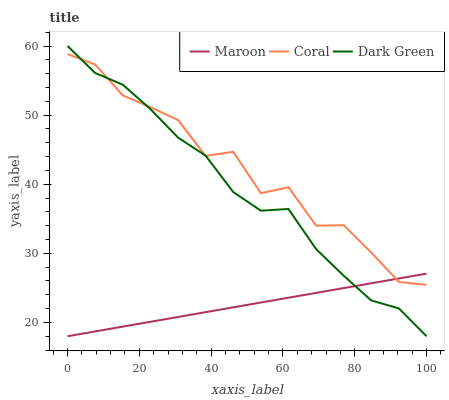Does Maroon have the minimum area under the curve?
Answer yes or no. Yes. Does Coral have the maximum area under the curve?
Answer yes or no. Yes. Does Dark Green have the minimum area under the curve?
Answer yes or no. No. Does Dark Green have the maximum area under the curve?
Answer yes or no. No. Is Maroon the smoothest?
Answer yes or no. Yes. Is Coral the roughest?
Answer yes or no. Yes. Is Dark Green the smoothest?
Answer yes or no. No. Is Dark Green the roughest?
Answer yes or no. No. Does Maroon have the lowest value?
Answer yes or no. Yes. Does Dark Green have the highest value?
Answer yes or no. Yes. Does Maroon have the highest value?
Answer yes or no. No. Does Dark Green intersect Coral?
Answer yes or no. Yes. Is Dark Green less than Coral?
Answer yes or no. No. Is Dark Green greater than Coral?
Answer yes or no. No. 